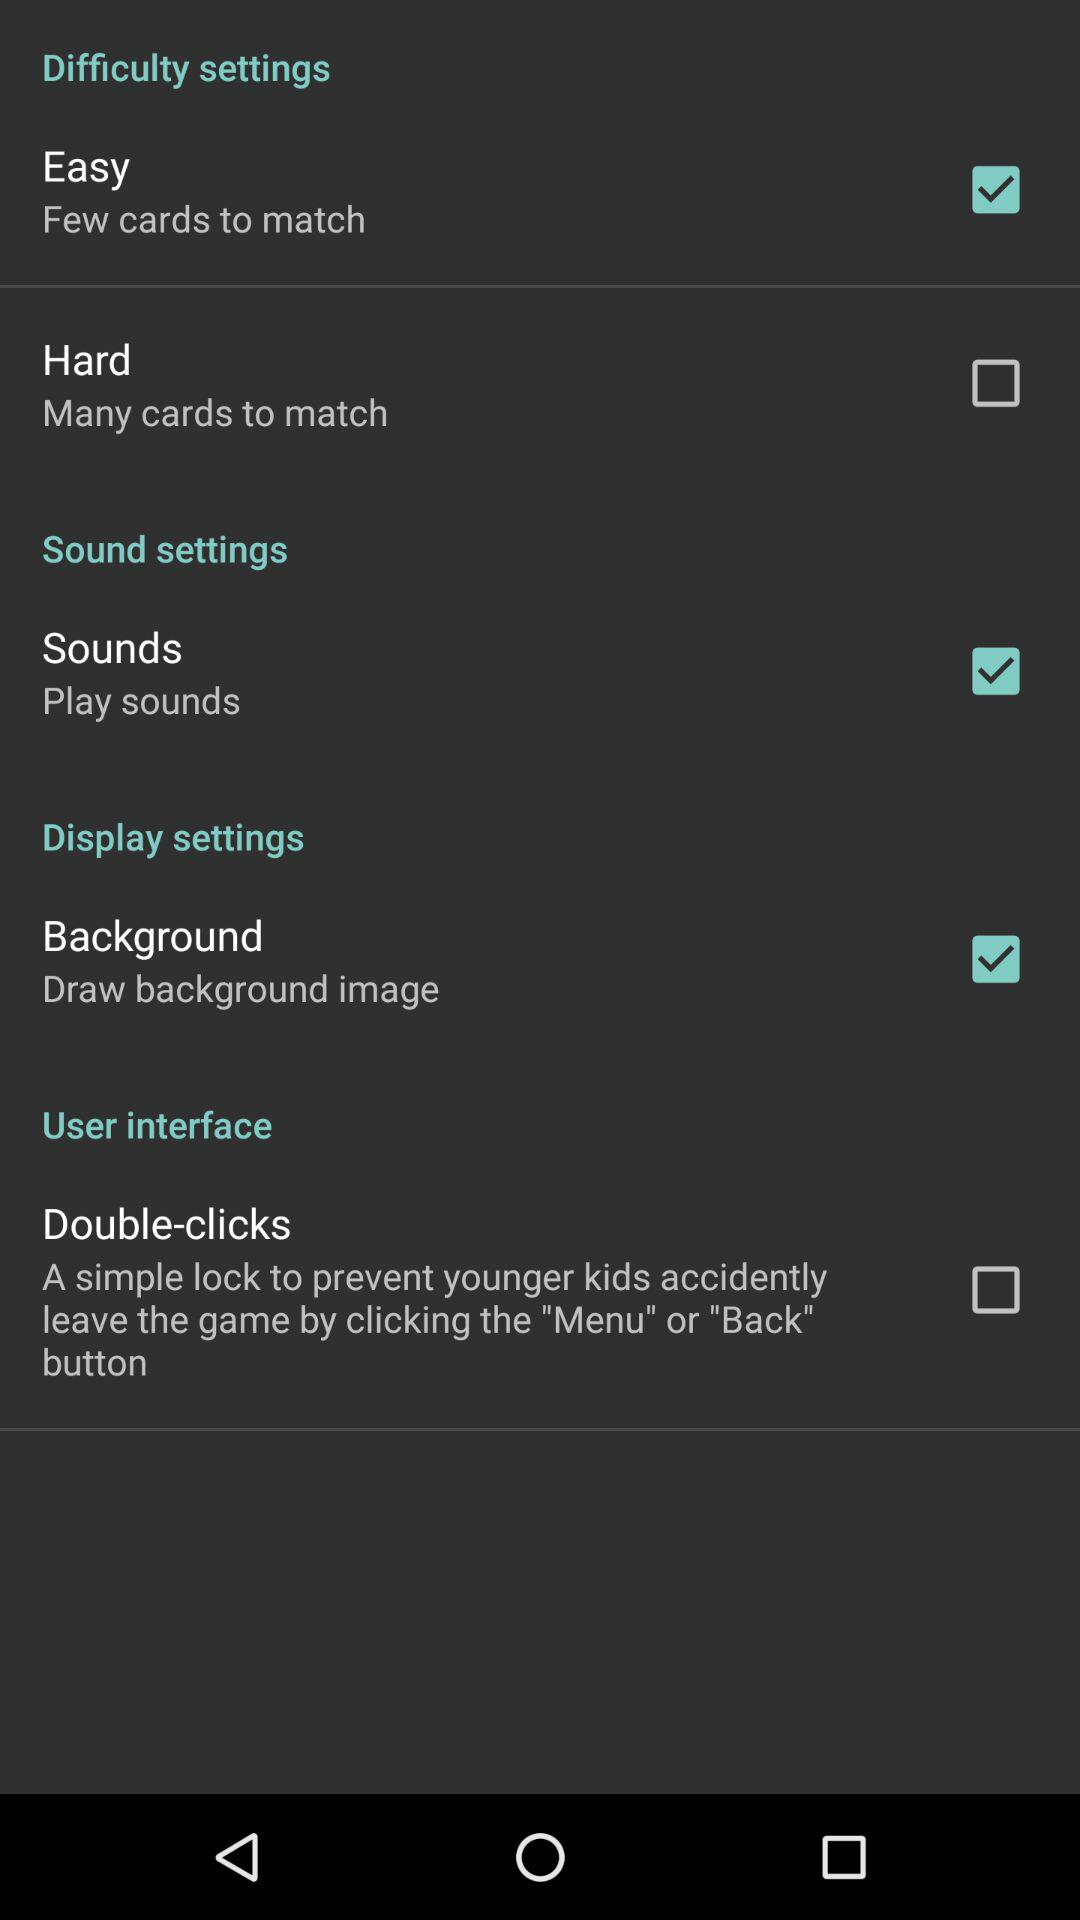What is the status of "Easy"? The status is "on". 